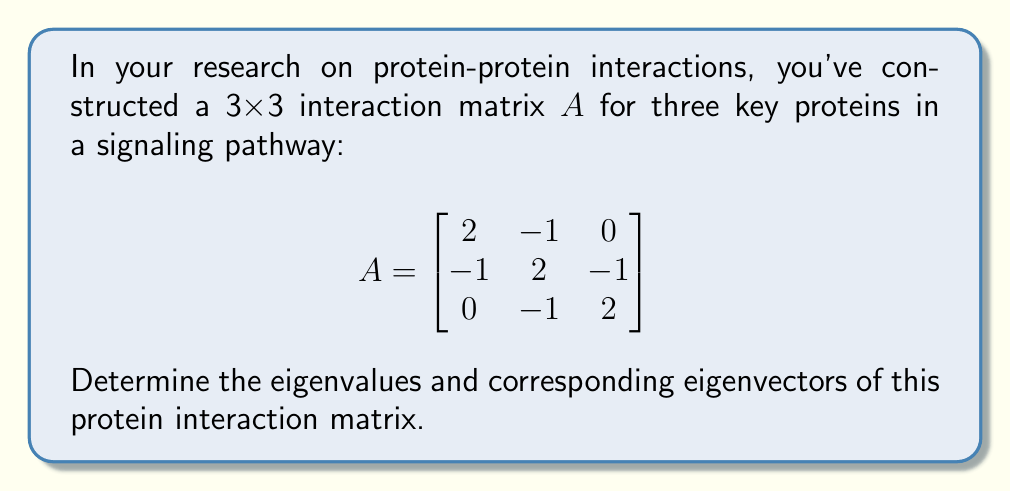Solve this math problem. To find the eigenvalues and eigenvectors of matrix $A$, we follow these steps:

1) Find the characteristic equation:
   $det(A - \lambda I) = 0$
   
   $$\begin{vmatrix}
   2-\lambda & -1 & 0 \\
   -1 & 2-\lambda & -1 \\
   0 & -1 & 2-\lambda
   \end{vmatrix} = 0$$

2) Expand the determinant:
   $(2-\lambda)[(2-\lambda)(2-\lambda) - 1] - (-1)[-1(2-\lambda) - 0] = 0$
   $(2-\lambda)[(2-\lambda)^2 - 1] + (2-\lambda) = 0$
   $(2-\lambda)[(2-\lambda)^2 - 1 + 1] = 0$
   $(2-\lambda)[(2-\lambda)^2] = 0$
   $(2-\lambda)^3 = 0$

3) Solve for $\lambda$:
   $\lambda = 2$ (with algebraic multiplicity 3)

4) Find the eigenvectors for $\lambda = 2$:
   $(A - 2I)\vec{v} = \vec{0}$
   
   $$\begin{bmatrix}
   0 & -1 & 0 \\
   -1 & 0 & -1 \\
   0 & -1 & 0
   \end{bmatrix}\begin{bmatrix}
   v_1 \\ v_2 \\ v_3
   \end{bmatrix} = \begin{bmatrix}
   0 \\ 0 \\ 0
   \end{bmatrix}$$

   This gives us:
   $-v_2 = 0$
   $-v_1 - v_3 = 0$
   $-v_2 = 0$

   We can choose $v_1 = 1$, which gives $v_3 = -1$ and $v_2 = 0$.

5) The eigenvector is:
   $\vec{v} = \begin{bmatrix} 1 \\ 0 \\ -1 \end{bmatrix}$

   Note: Since the eigenvalue has algebraic multiplicity 3 but geometric multiplicity 1, the matrix is defective and we cannot find three linearly independent eigenvectors.
Answer: Eigenvalue: $\lambda = 2$ (multiplicity 3)
Eigenvector: $\vec{v} = \begin{bmatrix} 1 \\ 0 \\ -1 \end{bmatrix}$ 